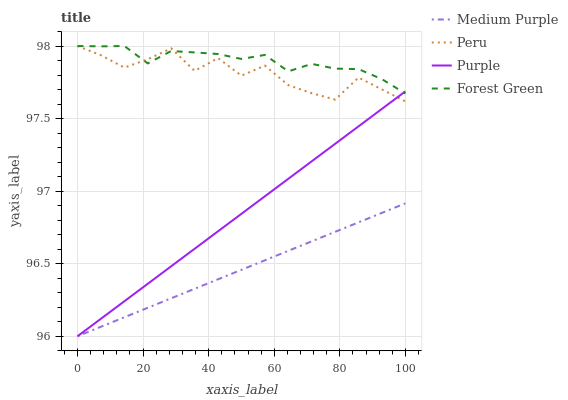Does Medium Purple have the minimum area under the curve?
Answer yes or no. Yes. Does Forest Green have the maximum area under the curve?
Answer yes or no. Yes. Does Purple have the minimum area under the curve?
Answer yes or no. No. Does Purple have the maximum area under the curve?
Answer yes or no. No. Is Purple the smoothest?
Answer yes or no. Yes. Is Peru the roughest?
Answer yes or no. Yes. Is Forest Green the smoothest?
Answer yes or no. No. Is Forest Green the roughest?
Answer yes or no. No. Does Forest Green have the lowest value?
Answer yes or no. No. Does Peru have the highest value?
Answer yes or no. Yes. Does Purple have the highest value?
Answer yes or no. No. Is Medium Purple less than Forest Green?
Answer yes or no. Yes. Is Peru greater than Medium Purple?
Answer yes or no. Yes. Does Purple intersect Peru?
Answer yes or no. Yes. Is Purple less than Peru?
Answer yes or no. No. Is Purple greater than Peru?
Answer yes or no. No. Does Medium Purple intersect Forest Green?
Answer yes or no. No. 